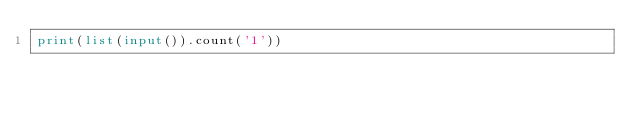<code> <loc_0><loc_0><loc_500><loc_500><_Python_>print(list(input()).count('1'))</code> 